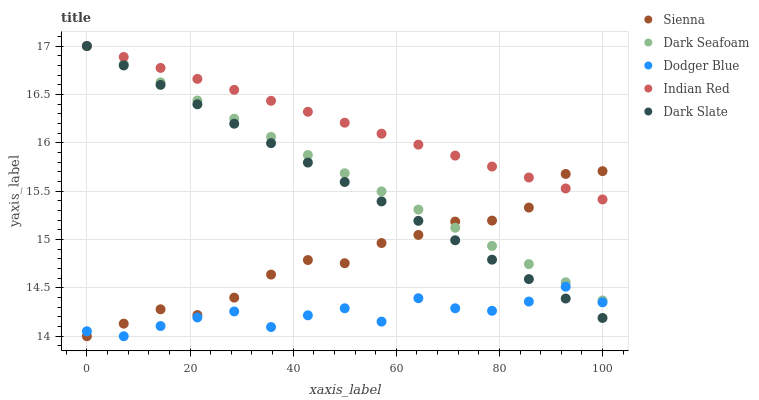Does Dodger Blue have the minimum area under the curve?
Answer yes or no. Yes. Does Indian Red have the maximum area under the curve?
Answer yes or no. Yes. Does Dark Slate have the minimum area under the curve?
Answer yes or no. No. Does Dark Slate have the maximum area under the curve?
Answer yes or no. No. Is Indian Red the smoothest?
Answer yes or no. Yes. Is Dodger Blue the roughest?
Answer yes or no. Yes. Is Dark Slate the smoothest?
Answer yes or no. No. Is Dark Slate the roughest?
Answer yes or no. No. Does Sienna have the lowest value?
Answer yes or no. Yes. Does Dark Slate have the lowest value?
Answer yes or no. No. Does Indian Red have the highest value?
Answer yes or no. Yes. Does Dodger Blue have the highest value?
Answer yes or no. No. Is Dodger Blue less than Indian Red?
Answer yes or no. Yes. Is Indian Red greater than Dodger Blue?
Answer yes or no. Yes. Does Sienna intersect Dark Seafoam?
Answer yes or no. Yes. Is Sienna less than Dark Seafoam?
Answer yes or no. No. Is Sienna greater than Dark Seafoam?
Answer yes or no. No. Does Dodger Blue intersect Indian Red?
Answer yes or no. No. 